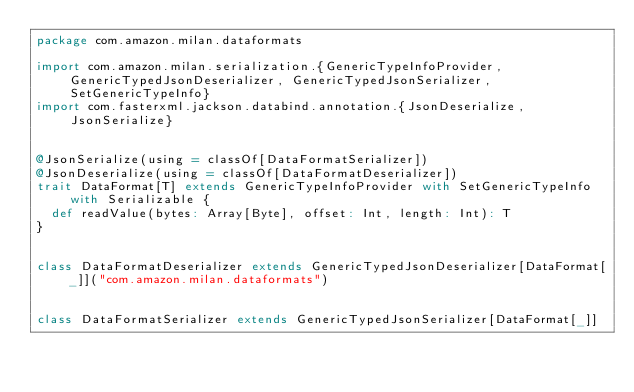<code> <loc_0><loc_0><loc_500><loc_500><_Scala_>package com.amazon.milan.dataformats

import com.amazon.milan.serialization.{GenericTypeInfoProvider, GenericTypedJsonDeserializer, GenericTypedJsonSerializer, SetGenericTypeInfo}
import com.fasterxml.jackson.databind.annotation.{JsonDeserialize, JsonSerialize}


@JsonSerialize(using = classOf[DataFormatSerializer])
@JsonDeserialize(using = classOf[DataFormatDeserializer])
trait DataFormat[T] extends GenericTypeInfoProvider with SetGenericTypeInfo with Serializable {
  def readValue(bytes: Array[Byte], offset: Int, length: Int): T
}


class DataFormatDeserializer extends GenericTypedJsonDeserializer[DataFormat[_]]("com.amazon.milan.dataformats")


class DataFormatSerializer extends GenericTypedJsonSerializer[DataFormat[_]]
</code> 